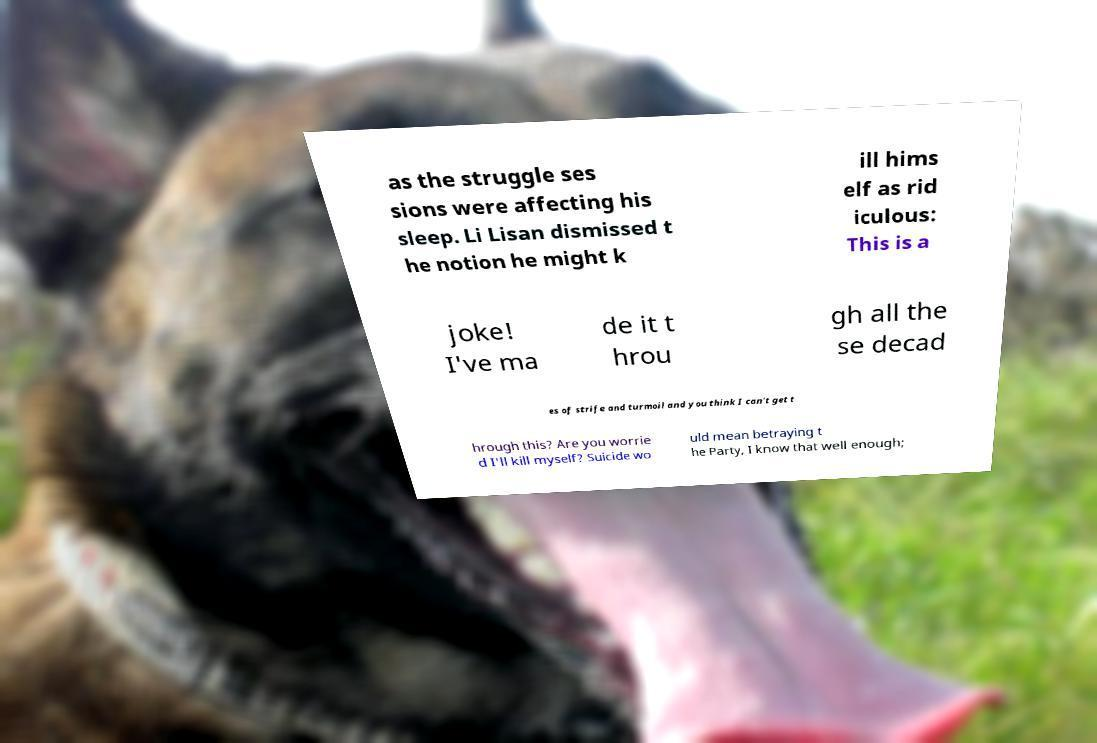What messages or text are displayed in this image? I need them in a readable, typed format. as the struggle ses sions were affecting his sleep. Li Lisan dismissed t he notion he might k ill hims elf as rid iculous: This is a joke! I've ma de it t hrou gh all the se decad es of strife and turmoil and you think I can't get t hrough this? Are you worrie d I'll kill myself? Suicide wo uld mean betraying t he Party, I know that well enough; 